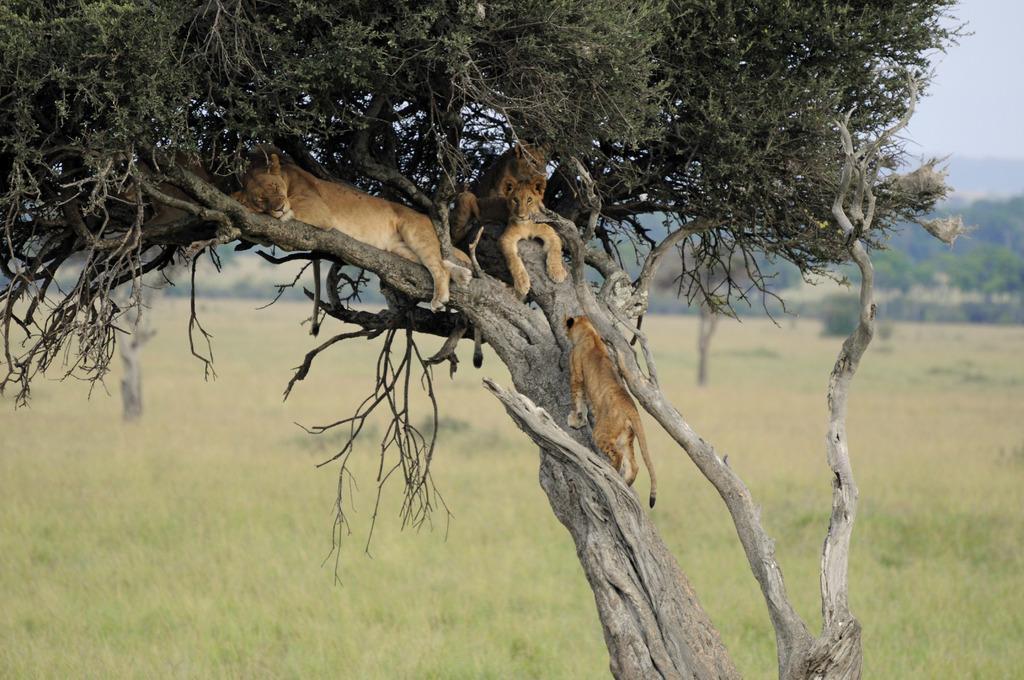Please provide a concise description of this image. At the bottom of the image I can see the grass. In the middle of the image I can see trees and animals. In the background, I can see groups of trees. There is a sky on the top of this image. The given image is blurred. 